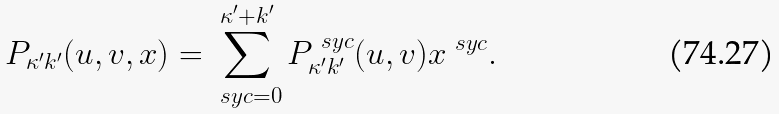Convert formula to latex. <formula><loc_0><loc_0><loc_500><loc_500>P _ { \kappa ^ { \prime } k ^ { \prime } } ( u , v , x ) = \sum _ { \ s y c = 0 } ^ { \kappa ^ { \prime } + k ^ { \prime } } P _ { \kappa ^ { \prime } k ^ { \prime } } ^ { \ s y c } ( u , v ) x ^ { \ s y c } .</formula> 